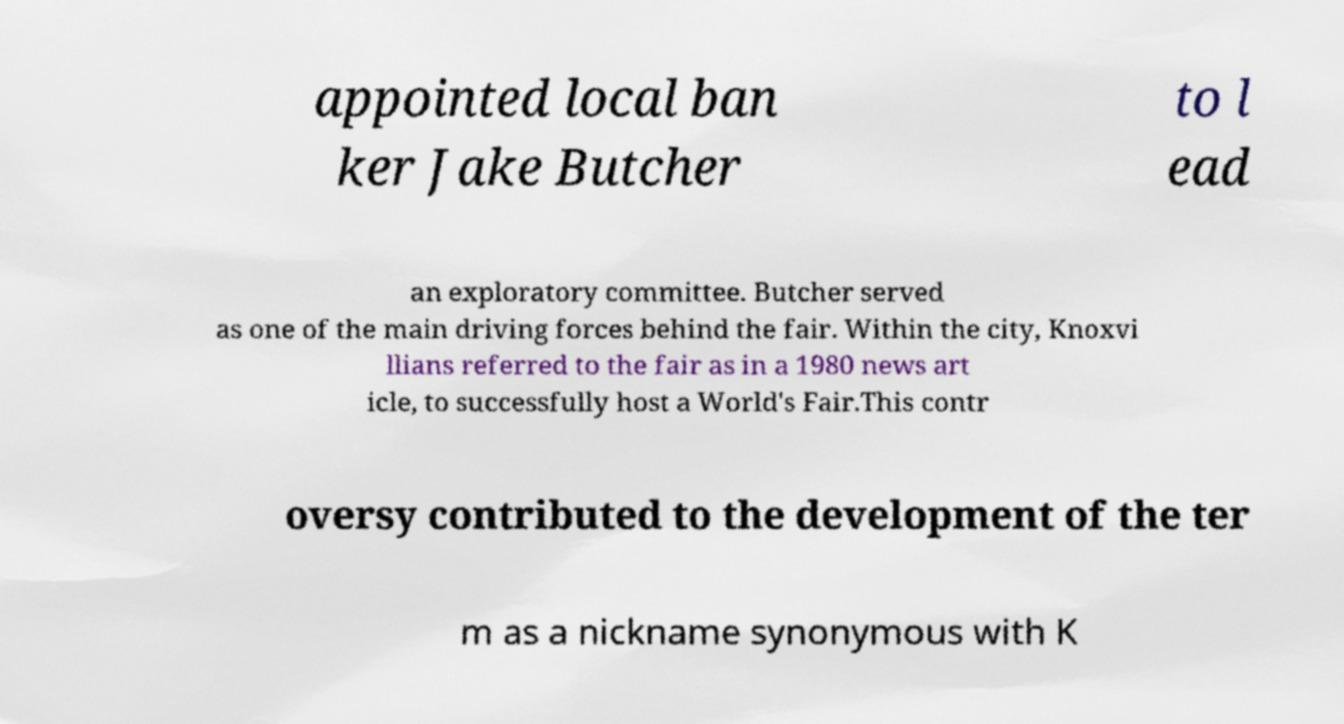I need the written content from this picture converted into text. Can you do that? appointed local ban ker Jake Butcher to l ead an exploratory committee. Butcher served as one of the main driving forces behind the fair. Within the city, Knoxvi llians referred to the fair as in a 1980 news art icle, to successfully host a World's Fair.This contr oversy contributed to the development of the ter m as a nickname synonymous with K 